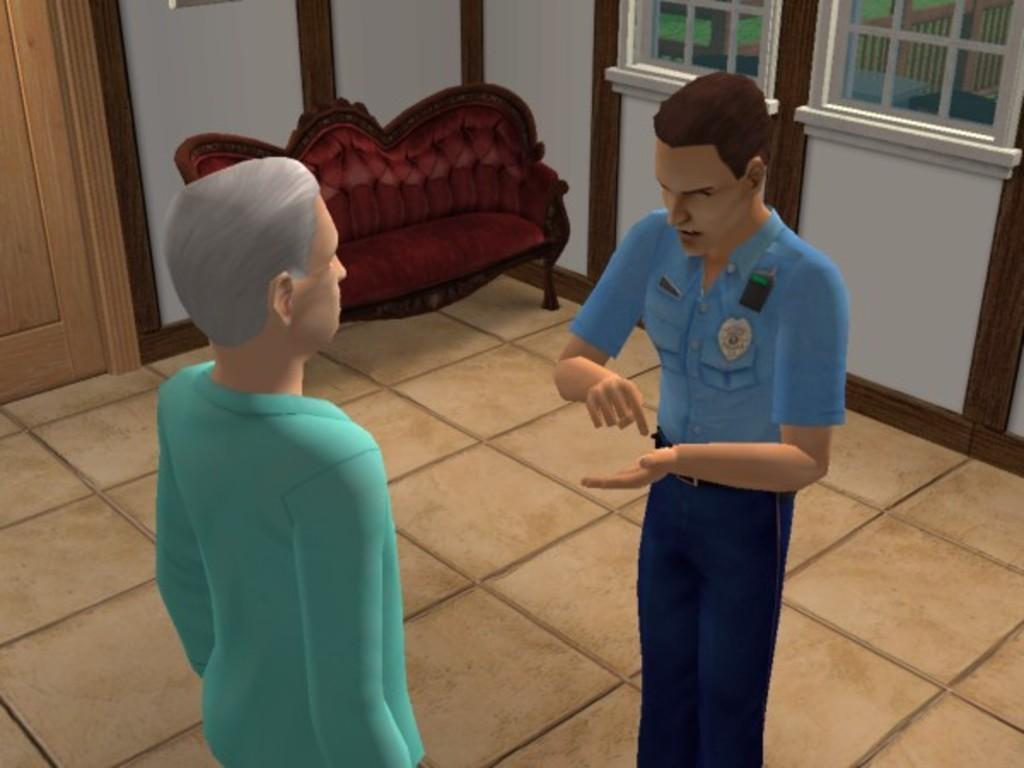Describe this image in one or two sentences. This is an animated image. There are a few people. We can see the ground and the wall. We can also see the sofa and some wood on the left. We can also see some glass windows. We can see some grass and the fence. 